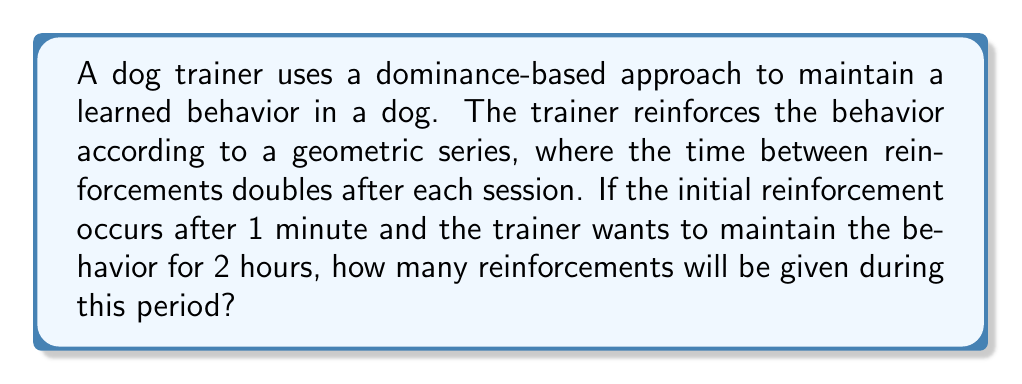What is the answer to this math problem? Let's approach this step-by-step:

1) The reinforcement times form a geometric sequence with first term $a_1 = 1$ minute and common ratio $r = 2$.

2) The nth term of this sequence is given by $a_n = a_1 \cdot r^{n-1} = 1 \cdot 2^{n-1}$ minutes.

3) We need to find the largest n such that the sum of the first n terms is less than or equal to 120 minutes (2 hours).

4) The sum of a geometric series is given by:

   $$S_n = \frac{a_1(1-r^n)}{1-r} = \frac{1(1-2^n)}{1-2} = 2^n - 1$$

5) We need to solve:

   $$2^n - 1 \leq 120$$

6) Adding 1 to both sides:

   $$2^n \leq 121$$

7) Taking log base 2 of both sides:

   $$n \leq \log_2(121) \approx 6.92$$

8) Since n must be an integer, the largest value it can take is 6.

Therefore, the trainer will give 6 reinforcements during the 2-hour period.
Answer: 6 reinforcements 